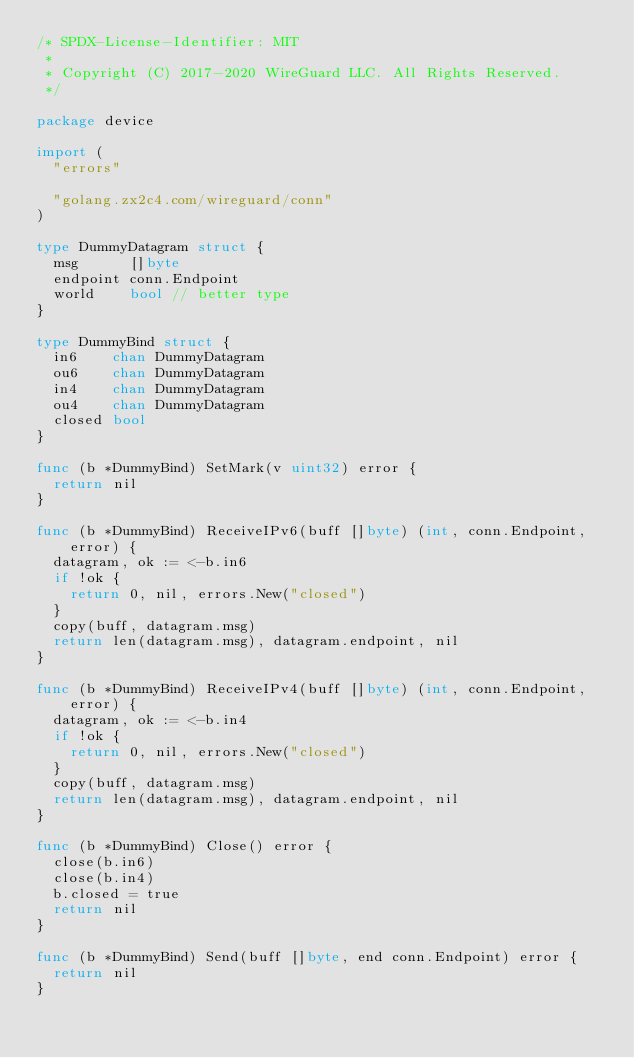<code> <loc_0><loc_0><loc_500><loc_500><_Go_>/* SPDX-License-Identifier: MIT
 *
 * Copyright (C) 2017-2020 WireGuard LLC. All Rights Reserved.
 */

package device

import (
	"errors"

	"golang.zx2c4.com/wireguard/conn"
)

type DummyDatagram struct {
	msg      []byte
	endpoint conn.Endpoint
	world    bool // better type
}

type DummyBind struct {
	in6    chan DummyDatagram
	ou6    chan DummyDatagram
	in4    chan DummyDatagram
	ou4    chan DummyDatagram
	closed bool
}

func (b *DummyBind) SetMark(v uint32) error {
	return nil
}

func (b *DummyBind) ReceiveIPv6(buff []byte) (int, conn.Endpoint, error) {
	datagram, ok := <-b.in6
	if !ok {
		return 0, nil, errors.New("closed")
	}
	copy(buff, datagram.msg)
	return len(datagram.msg), datagram.endpoint, nil
}

func (b *DummyBind) ReceiveIPv4(buff []byte) (int, conn.Endpoint, error) {
	datagram, ok := <-b.in4
	if !ok {
		return 0, nil, errors.New("closed")
	}
	copy(buff, datagram.msg)
	return len(datagram.msg), datagram.endpoint, nil
}

func (b *DummyBind) Close() error {
	close(b.in6)
	close(b.in4)
	b.closed = true
	return nil
}

func (b *DummyBind) Send(buff []byte, end conn.Endpoint) error {
	return nil
}
</code> 